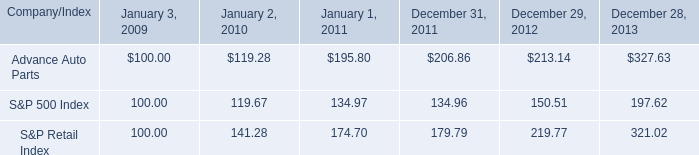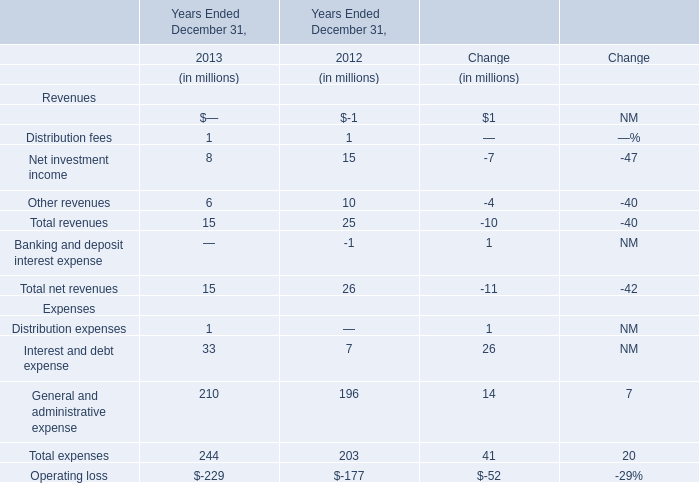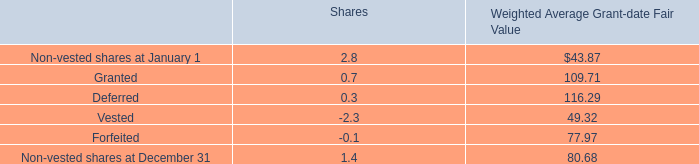What's the sum of revenues without those revenues smaller than 5 in 2013? (in million) 
Computations: (8 + 6)
Answer: 14.0. 